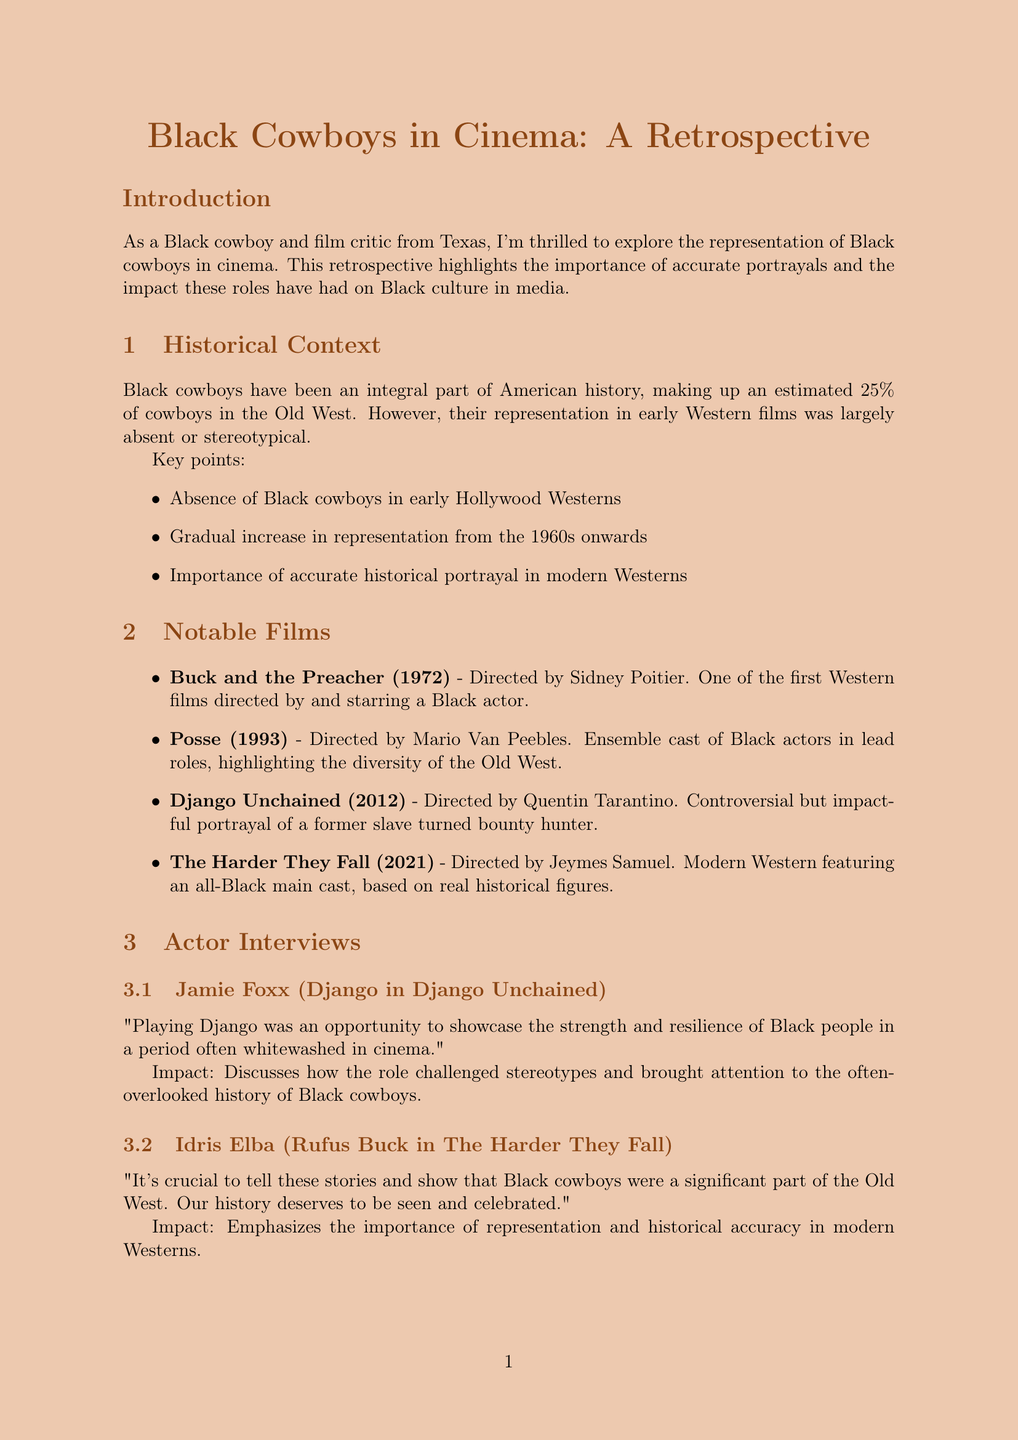What percentage of cowboys in the Old West were Black? The document states that Black cowboys made up an estimated 25% of cowboys in the Old West.
Answer: 25% Who directed "Buck and the Preacher"? The document lists Sidney Poitier as the director of "Buck and the Preacher".
Answer: Sidney Poitier What year was "Django Unchained" released? The document mentions that "Django Unchained" was released in 2012.
Answer: 2012 Which actor played Django in "Django Unchained"? The interview section provides information that Jamie Foxx played the role of Django.
Answer: Jamie Foxx What impact did Glynn Turman mention regarding playing a Black cowboy in the '70s? Glynn Turman noted that playing a Black cowboy was revolutionary and opened doors for future generations.
Answer: Opened doors How has representation of Black cowboys inspired Black youth? The document states that it inspires Black youth to embrace cowboy culture.
Answer: Embrace cowboy culture What is one key point mentioned in the impact on Black culture section? One of the key points is the increased awareness of Black contributions to the Old West.
Answer: Increased awareness What is the notable Texan cowboy listed in the Texas connection section? The document includes Bose Ikard as a notable Texan cowboy.
Answer: Bose Ikard What is the significance of "The Harder They Fall" in terms of casting? The film features an all-Black main cast.
Answer: All-Black main cast 